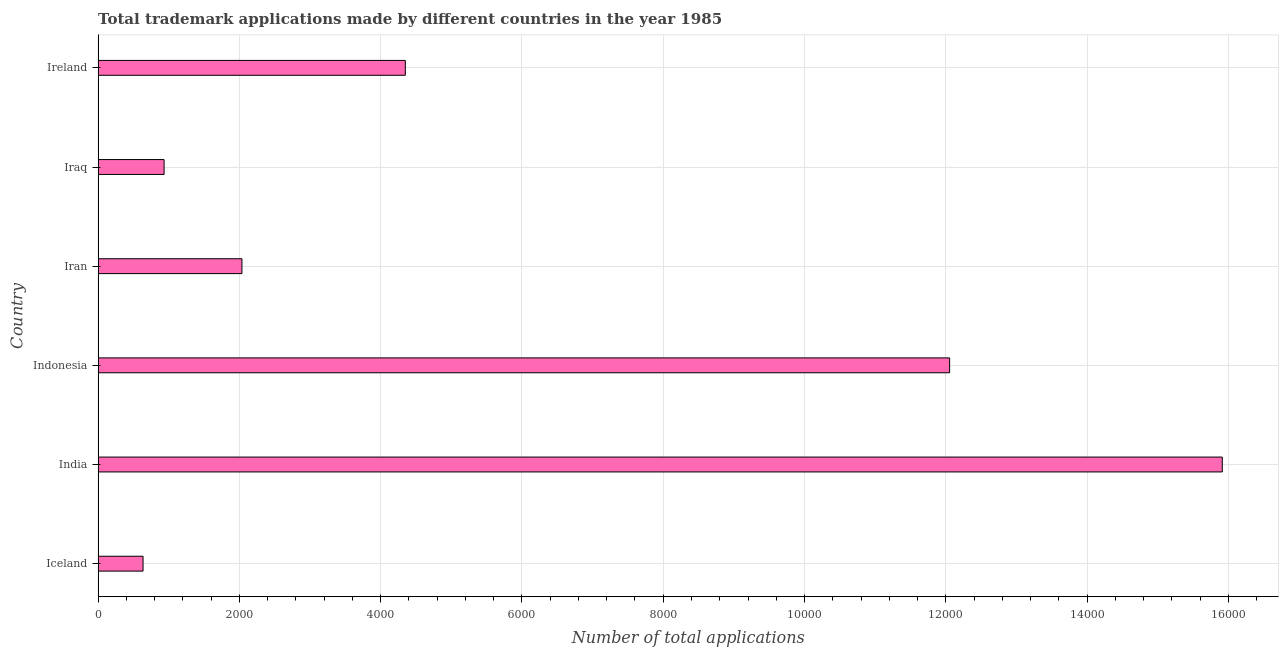Does the graph contain grids?
Your response must be concise. Yes. What is the title of the graph?
Ensure brevity in your answer.  Total trademark applications made by different countries in the year 1985. What is the label or title of the X-axis?
Keep it short and to the point. Number of total applications. What is the number of trademark applications in Ireland?
Make the answer very short. 4349. Across all countries, what is the maximum number of trademark applications?
Provide a short and direct response. 1.59e+04. Across all countries, what is the minimum number of trademark applications?
Your response must be concise. 636. What is the sum of the number of trademark applications?
Provide a succinct answer. 3.59e+04. What is the difference between the number of trademark applications in Iran and Iraq?
Ensure brevity in your answer.  1102. What is the average number of trademark applications per country?
Keep it short and to the point. 5987. What is the median number of trademark applications?
Your answer should be very brief. 3192.5. In how many countries, is the number of trademark applications greater than 12800 ?
Give a very brief answer. 1. What is the ratio of the number of trademark applications in Indonesia to that in Iran?
Your response must be concise. 5.92. What is the difference between the highest and the second highest number of trademark applications?
Make the answer very short. 3860. What is the difference between the highest and the lowest number of trademark applications?
Your answer should be compact. 1.53e+04. In how many countries, is the number of trademark applications greater than the average number of trademark applications taken over all countries?
Provide a short and direct response. 2. Are all the bars in the graph horizontal?
Ensure brevity in your answer.  Yes. Are the values on the major ticks of X-axis written in scientific E-notation?
Offer a very short reply. No. What is the Number of total applications in Iceland?
Make the answer very short. 636. What is the Number of total applications in India?
Your response must be concise. 1.59e+04. What is the Number of total applications in Indonesia?
Ensure brevity in your answer.  1.21e+04. What is the Number of total applications of Iran?
Offer a terse response. 2036. What is the Number of total applications in Iraq?
Offer a terse response. 934. What is the Number of total applications of Ireland?
Ensure brevity in your answer.  4349. What is the difference between the Number of total applications in Iceland and India?
Keep it short and to the point. -1.53e+04. What is the difference between the Number of total applications in Iceland and Indonesia?
Your answer should be compact. -1.14e+04. What is the difference between the Number of total applications in Iceland and Iran?
Make the answer very short. -1400. What is the difference between the Number of total applications in Iceland and Iraq?
Your answer should be compact. -298. What is the difference between the Number of total applications in Iceland and Ireland?
Offer a terse response. -3713. What is the difference between the Number of total applications in India and Indonesia?
Offer a very short reply. 3860. What is the difference between the Number of total applications in India and Iran?
Your response must be concise. 1.39e+04. What is the difference between the Number of total applications in India and Iraq?
Provide a succinct answer. 1.50e+04. What is the difference between the Number of total applications in India and Ireland?
Ensure brevity in your answer.  1.16e+04. What is the difference between the Number of total applications in Indonesia and Iran?
Make the answer very short. 1.00e+04. What is the difference between the Number of total applications in Indonesia and Iraq?
Give a very brief answer. 1.11e+04. What is the difference between the Number of total applications in Indonesia and Ireland?
Your response must be concise. 7705. What is the difference between the Number of total applications in Iran and Iraq?
Offer a terse response. 1102. What is the difference between the Number of total applications in Iran and Ireland?
Give a very brief answer. -2313. What is the difference between the Number of total applications in Iraq and Ireland?
Your answer should be compact. -3415. What is the ratio of the Number of total applications in Iceland to that in Indonesia?
Give a very brief answer. 0.05. What is the ratio of the Number of total applications in Iceland to that in Iran?
Your response must be concise. 0.31. What is the ratio of the Number of total applications in Iceland to that in Iraq?
Give a very brief answer. 0.68. What is the ratio of the Number of total applications in Iceland to that in Ireland?
Keep it short and to the point. 0.15. What is the ratio of the Number of total applications in India to that in Indonesia?
Ensure brevity in your answer.  1.32. What is the ratio of the Number of total applications in India to that in Iran?
Provide a succinct answer. 7.82. What is the ratio of the Number of total applications in India to that in Iraq?
Keep it short and to the point. 17.04. What is the ratio of the Number of total applications in India to that in Ireland?
Your answer should be compact. 3.66. What is the ratio of the Number of total applications in Indonesia to that in Iran?
Make the answer very short. 5.92. What is the ratio of the Number of total applications in Indonesia to that in Iraq?
Give a very brief answer. 12.91. What is the ratio of the Number of total applications in Indonesia to that in Ireland?
Give a very brief answer. 2.77. What is the ratio of the Number of total applications in Iran to that in Iraq?
Your response must be concise. 2.18. What is the ratio of the Number of total applications in Iran to that in Ireland?
Your response must be concise. 0.47. What is the ratio of the Number of total applications in Iraq to that in Ireland?
Ensure brevity in your answer.  0.21. 